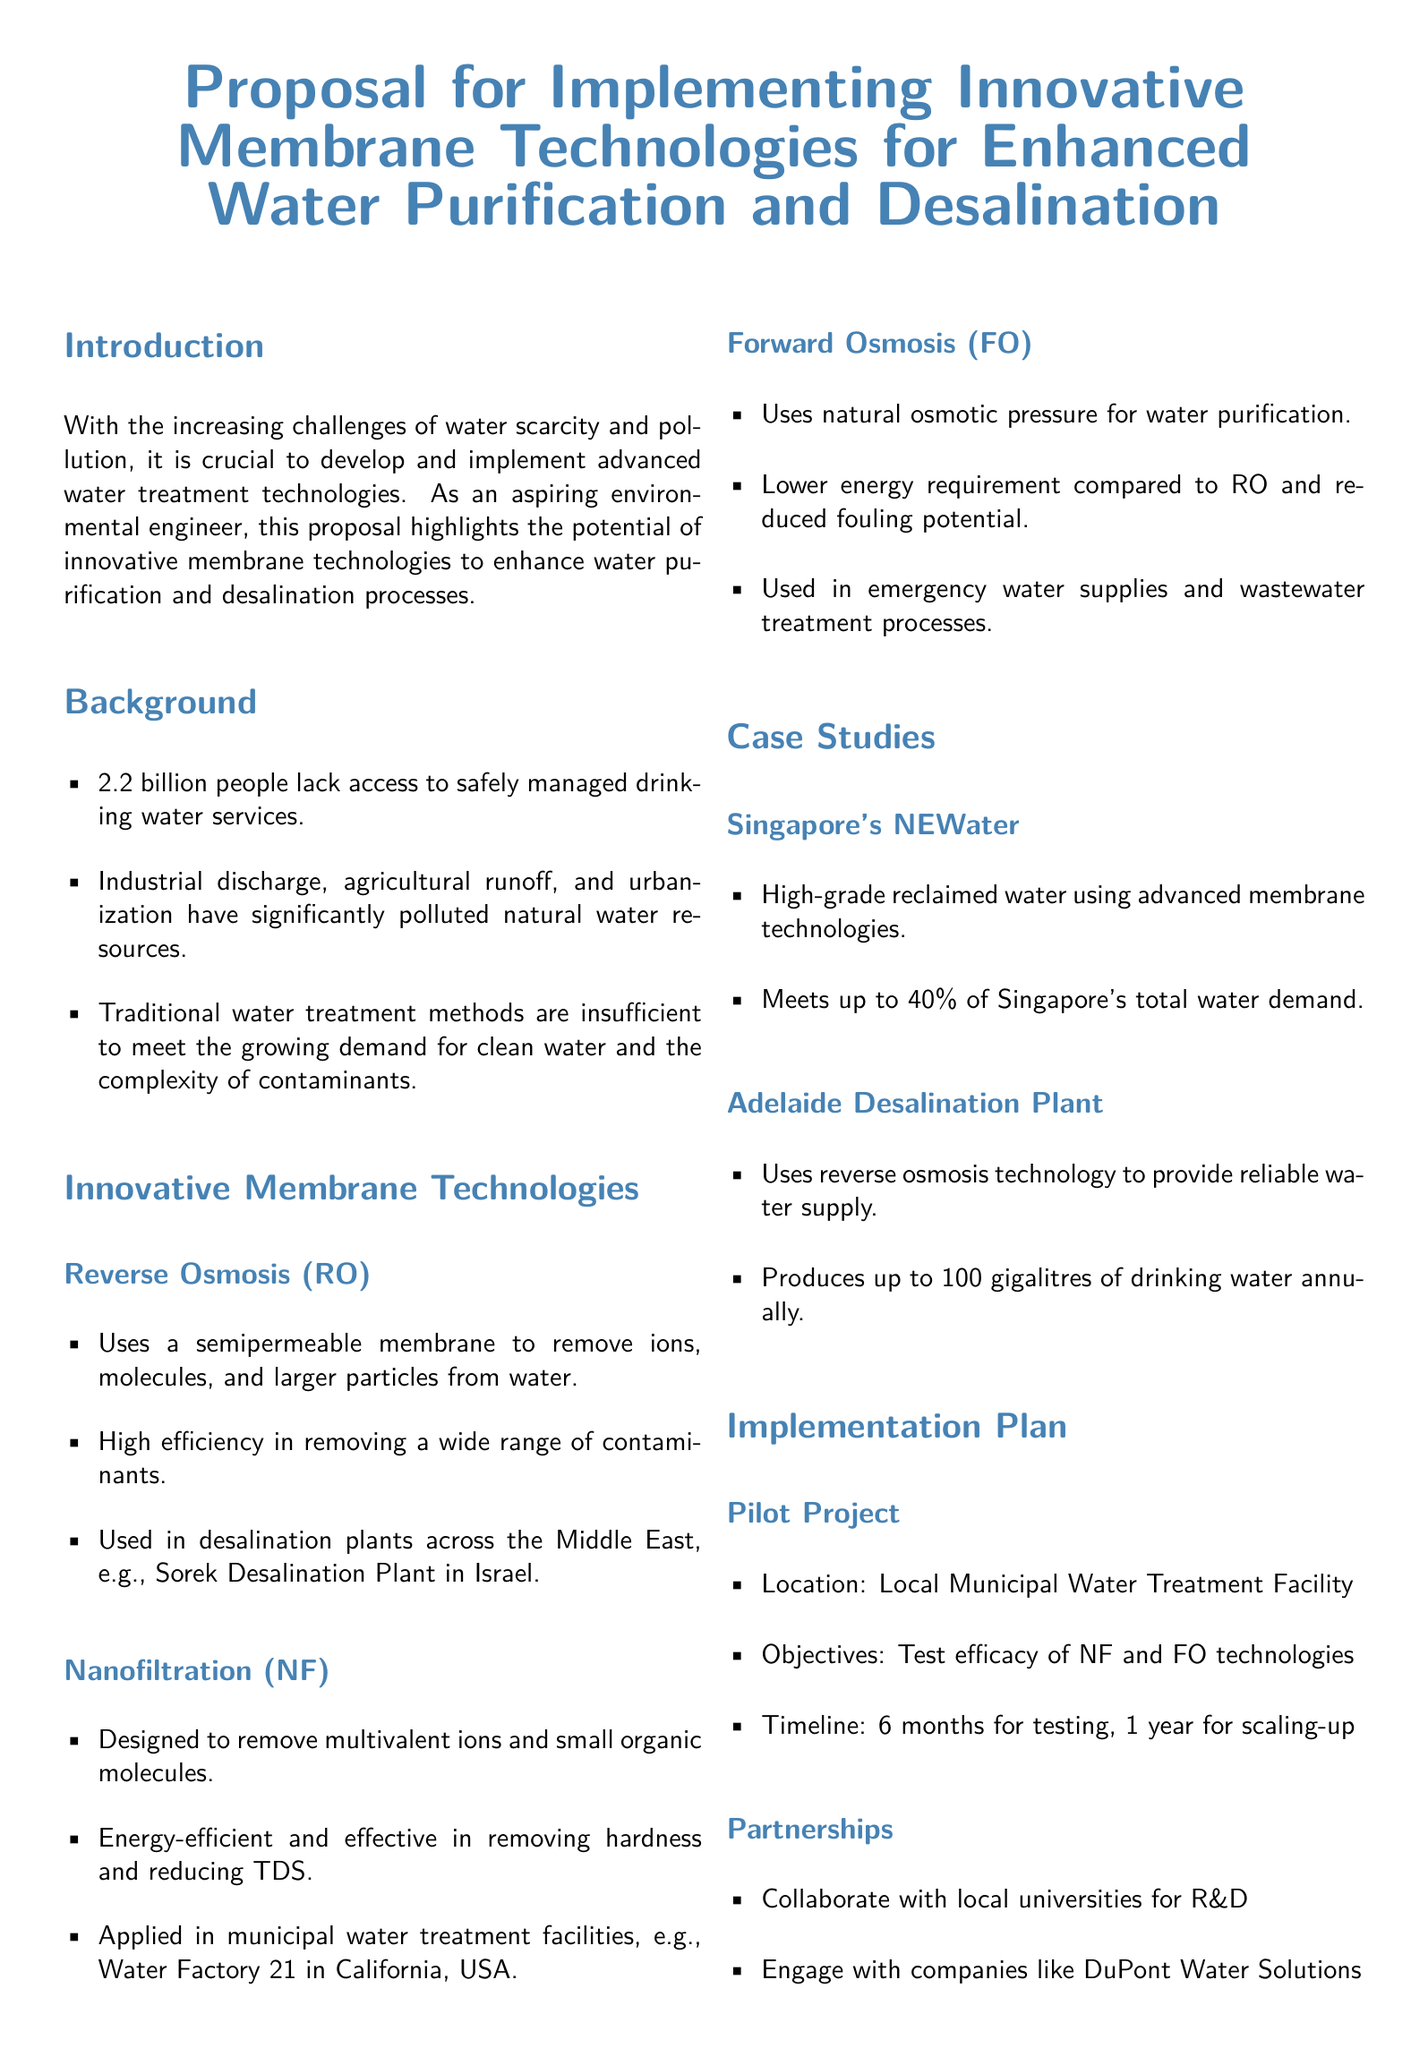What is the main focus of the proposal? The main focus of the proposal is to highlight the potential of innovative membrane technologies for water purification and desalination.
Answer: innovative membrane technologies for water purification and desalination How many people lack access to safely managed drinking water? The document states that 2.2 billion people lack access to safely managed drinking water services.
Answer: 2.2 billion Which technology is used in the Sorek Desalination Plant? The document specifies that the Sorek Desalination Plant in Israel uses reverse osmosis (RO) technology.
Answer: reverse osmosis (RO) What percentage of Singapore's water demand is met by NEWater? The proposal indicates that NEWater meets up to 40% of Singapore's total water demand.
Answer: 40% What is the timeline for the pilot project? The timeline for the pilot project includes 6 months for testing and 1 year for scaling-up.
Answer: 6 months for testing, 1 year for scaling-up Which two entities should be engaged for partnerships in the implementation plan? The document mentions collaborating with local universities for R&D and engaging with DuPont Water Solutions.
Answer: local universities and DuPont Water Solutions What is the annual production capacity of the Adelaide Desalination Plant? The Adelaide Desalination Plant produces up to 100 gigalitres of drinking water annually.
Answer: 100 gigalitres What are the two innovative membrane technologies tested in the pilot project? The pilot project aims to test the efficacy of nanofiltration (NF) and forward osmosis (FO) technologies.
Answer: nanofiltration (NF) and forward osmosis (FO) 